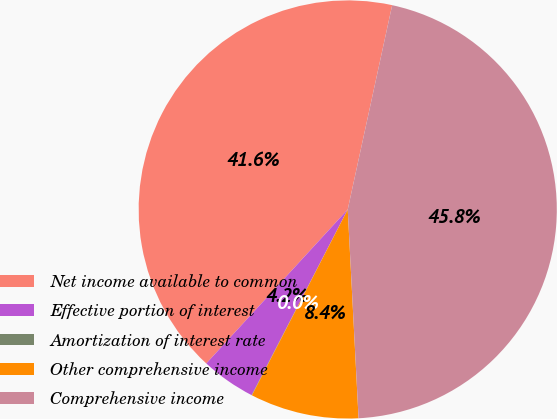Convert chart to OTSL. <chart><loc_0><loc_0><loc_500><loc_500><pie_chart><fcel>Net income available to common<fcel>Effective portion of interest<fcel>Amortization of interest rate<fcel>Other comprehensive income<fcel>Comprehensive income<nl><fcel>41.59%<fcel>4.22%<fcel>0.03%<fcel>8.4%<fcel>45.77%<nl></chart> 